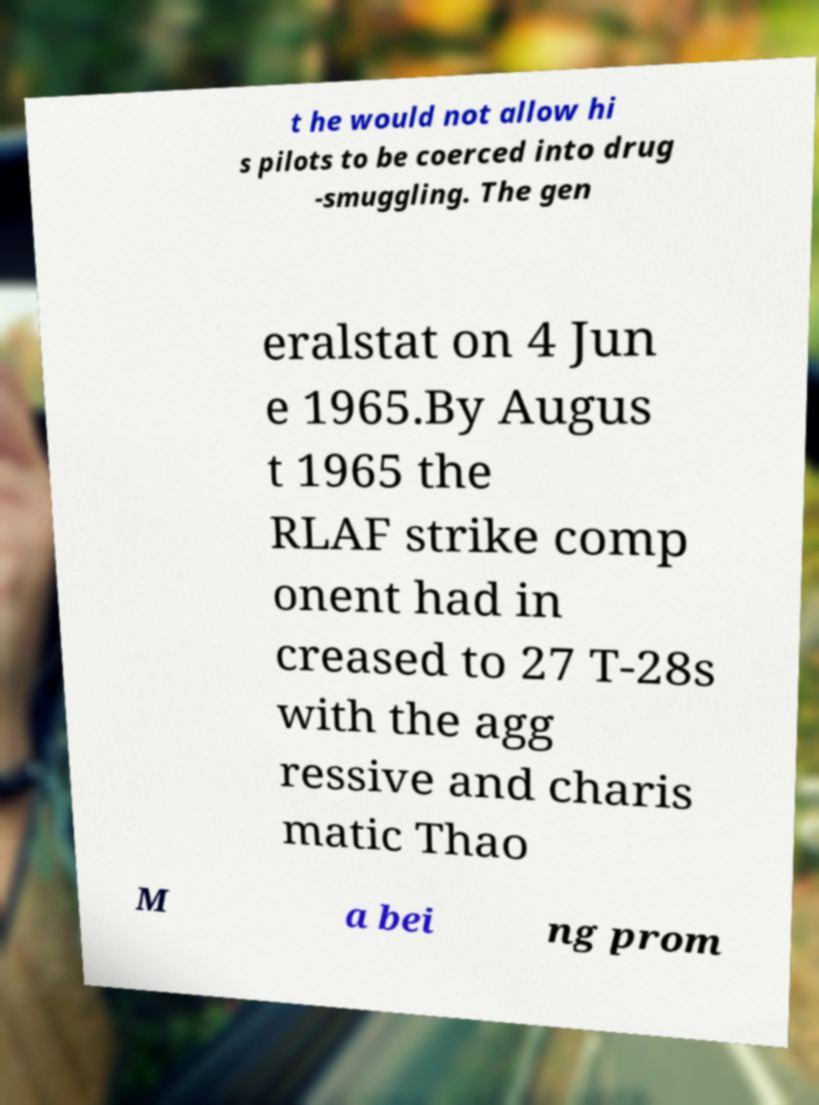What messages or text are displayed in this image? I need them in a readable, typed format. t he would not allow hi s pilots to be coerced into drug -smuggling. The gen eralstat on 4 Jun e 1965.By Augus t 1965 the RLAF strike comp onent had in creased to 27 T-28s with the agg ressive and charis matic Thao M a bei ng prom 